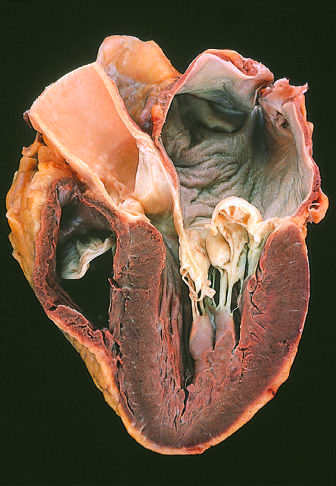s the surrounding lung dilated, reflecting long-standing valvular insufficiency and volume overload?
Answer the question using a single word or phrase. No 